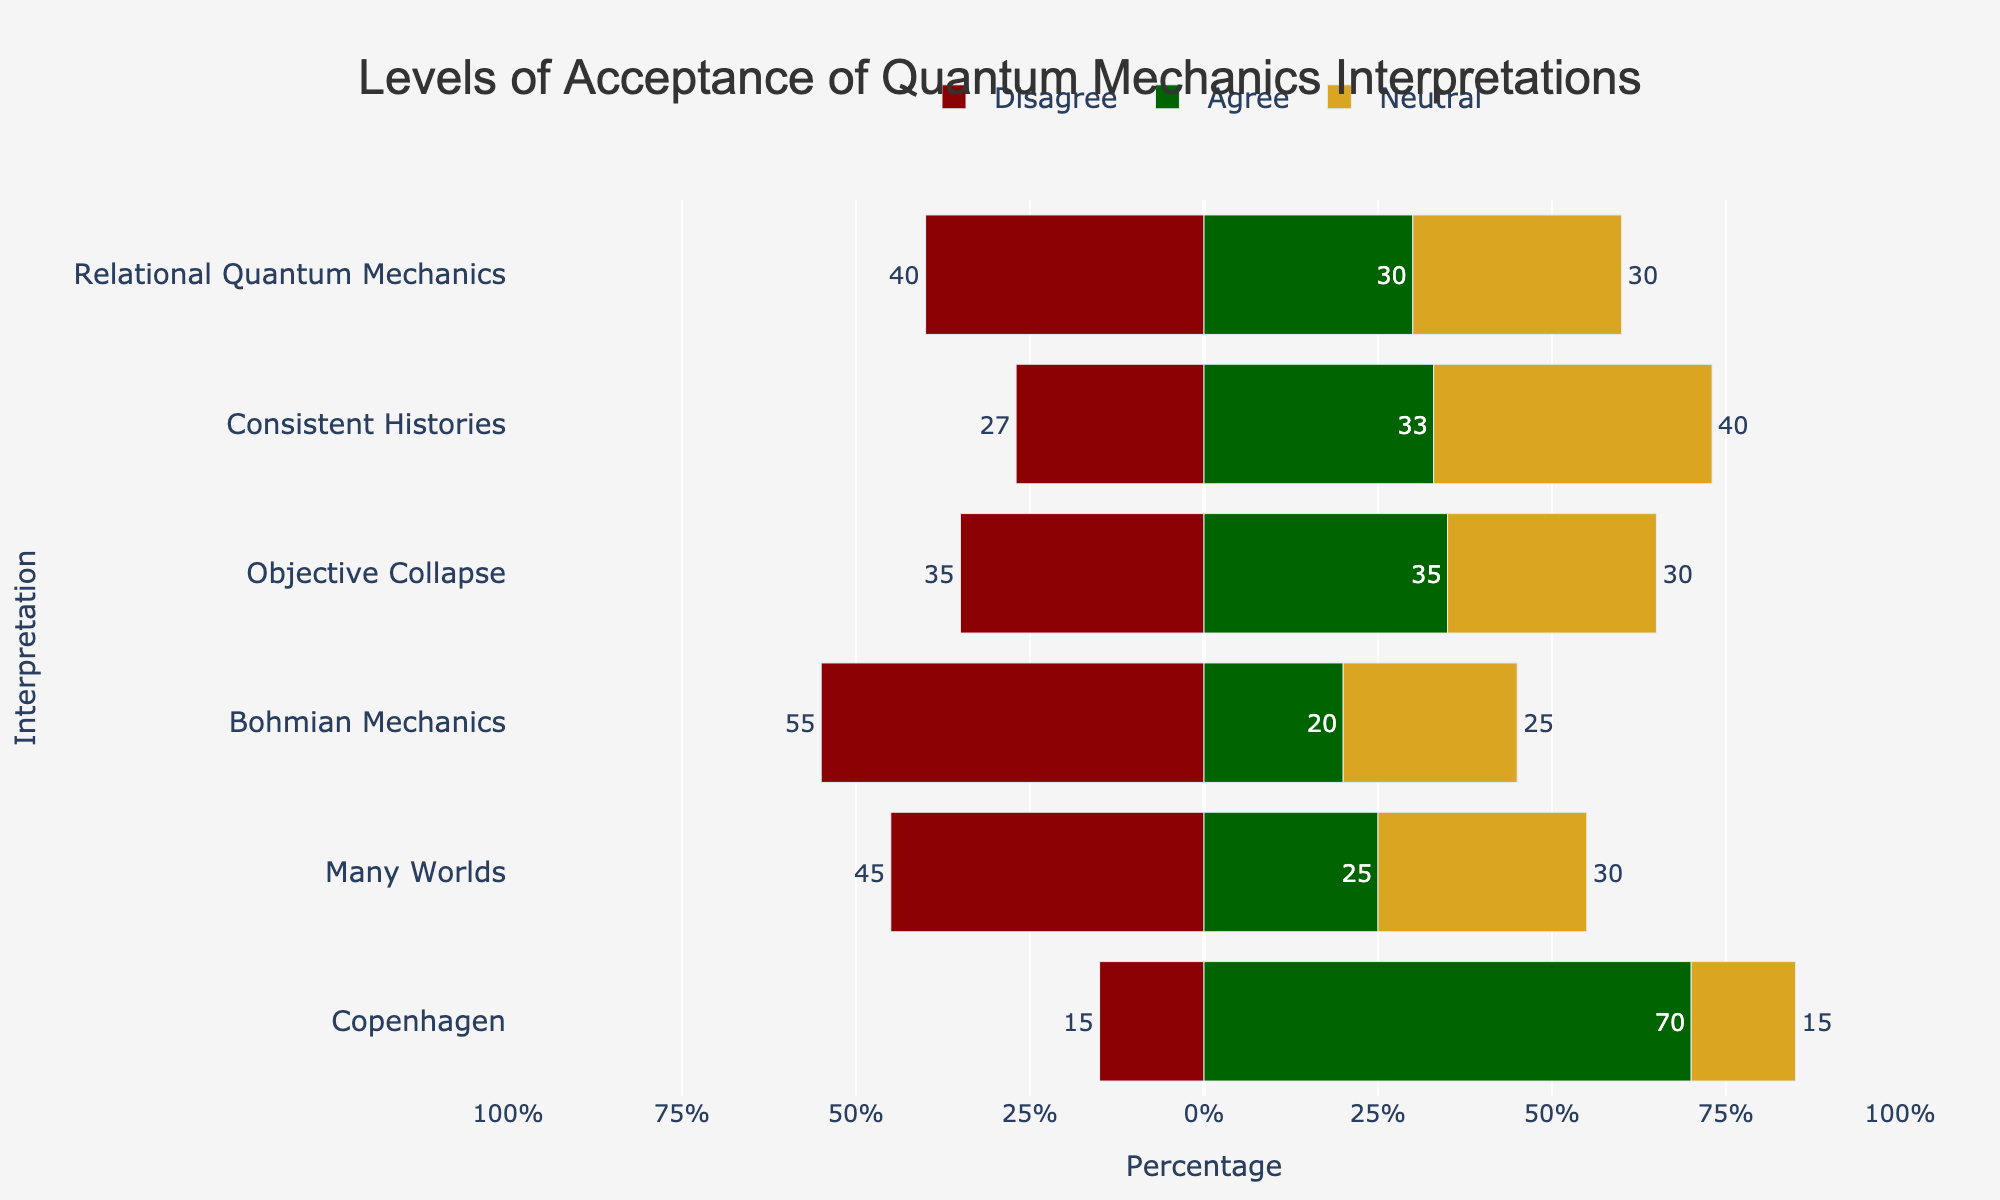Which interpretation has the highest level of strong agreement? According to the length of the green bars representing 'Strongly Agree' responses, Copenhagen has the longest green bar.
Answer: Copenhagen Which interpretation has more disagreement, Many Worlds or Bohmian Mechanics? By comparing the length of the red bars representing 'Disagree' responses, Bohmian Mechanics has a longer red bar than Many Worlds.
Answer: Bohmian Mechanics How many interpretations have a neutral percentage of exactly 30%? The interpretations with neutral values (golden bars) exactly at 30% are Many Worlds, Objective Collapse, and Relational Quantum Mechanics.
Answer: 3 Is there any interpretation where the levels of agreement outnumber the levels of disagreement? The levels of agreement (green bars) are higher than the levels of disagreement (red bars) in Copenhagen and Objective Collapse.
Answer: Yes What is the total percentage of philosophers who have positive views (Agree + Strongly Agree) about the Many Worlds interpretation? The values for 'Agree' and 'Strongly Agree' in Many Worlds are 15% and 10%, respectively. Summing them up gives 15 + 10 = 25%.
Answer: 25% Which interpretations have equal numbers of people agreeing and disagreeing? The green and red bars of equal length denote equal agreement and disagreement. Both Relational Quantum Mechanics and Bohmian Mechanics fit this criteria.
Answer: Relational Quantum Mechanics, Bohmian Mechanics How much higher is the neutral percentage in Consistent Histories compared to Objective Collapse? The neutral percentages for Consistent Histories and Objective Collapse are 40% and 30%, respectively. The difference is 40% - 30% = 10%.
Answer: 10% Which interpretation has the least degree of strong disagreement? The interpretation with the smallest red bar for 'Strongly Disagree' is Copenhagen.
Answer: Copenhagen For the Copenhagen interpretation, what is the combined percentage of philosophers who either disagree or feel neutral about it? The percentages for 'Strongly Disagree', 'Disagree', and 'Neutral' in Copenhagen are 5%, 10%, and 15%, respectively. Summing these gives 5 + 10 + 15 = 30%.
Answer: 30% 